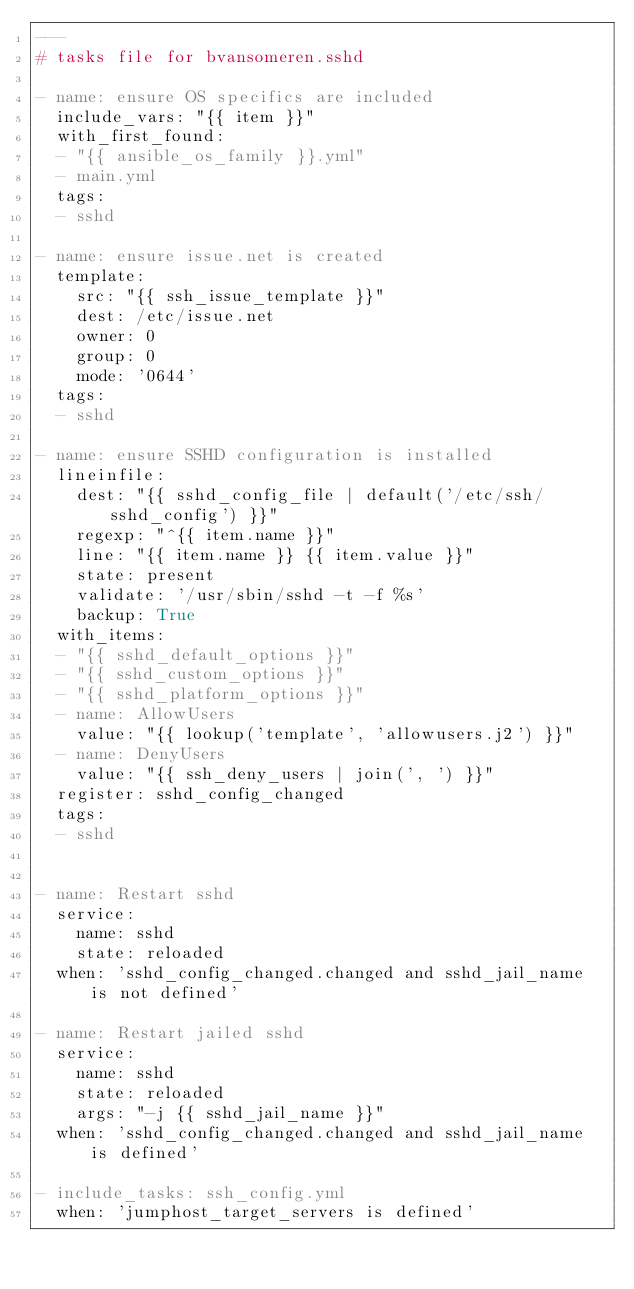<code> <loc_0><loc_0><loc_500><loc_500><_YAML_>---
# tasks file for bvansomeren.sshd

- name: ensure OS specifics are included
  include_vars: "{{ item }}"
  with_first_found:
  - "{{ ansible_os_family }}.yml"
  - main.yml
  tags:
  - sshd

- name: ensure issue.net is created
  template:
    src: "{{ ssh_issue_template }}"
    dest: /etc/issue.net
    owner: 0
    group: 0
    mode: '0644'
  tags:
  - sshd

- name: ensure SSHD configuration is installed
  lineinfile:
    dest: "{{ sshd_config_file | default('/etc/ssh/sshd_config') }}"
    regexp: "^{{ item.name }}"
    line: "{{ item.name }} {{ item.value }}"
    state: present
    validate: '/usr/sbin/sshd -t -f %s'
    backup: True
  with_items:
  - "{{ sshd_default_options }}"
  - "{{ sshd_custom_options }}"
  - "{{ sshd_platform_options }}"
  - name: AllowUsers
    value: "{{ lookup('template', 'allowusers.j2') }}"
  - name: DenyUsers
    value: "{{ ssh_deny_users | join(', ') }}"
  register: sshd_config_changed
  tags:
  - sshd


- name: Restart sshd
  service:
    name: sshd
    state: reloaded
  when: 'sshd_config_changed.changed and sshd_jail_name is not defined'

- name: Restart jailed sshd
  service:
    name: sshd
    state: reloaded
    args: "-j {{ sshd_jail_name }}"
  when: 'sshd_config_changed.changed and sshd_jail_name is defined'

- include_tasks: ssh_config.yml
  when: 'jumphost_target_servers is defined'
</code> 